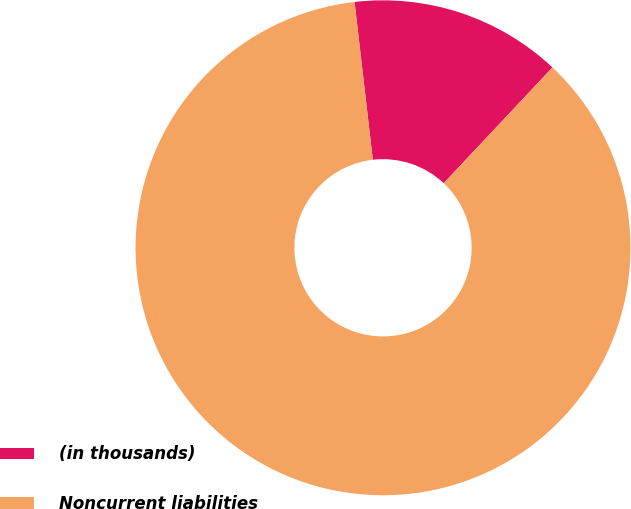<chart> <loc_0><loc_0><loc_500><loc_500><pie_chart><fcel>(in thousands)<fcel>Noncurrent liabilities<nl><fcel>13.84%<fcel>86.16%<nl></chart> 